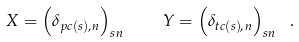<formula> <loc_0><loc_0><loc_500><loc_500>X = \left ( \delta _ { p c ( s ) , n } \right ) _ { s n } \quad Y = \left ( \delta _ { t c ( s ) , n } \right ) _ { s n } \ .</formula> 